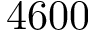<formula> <loc_0><loc_0><loc_500><loc_500>4 6 0 0</formula> 